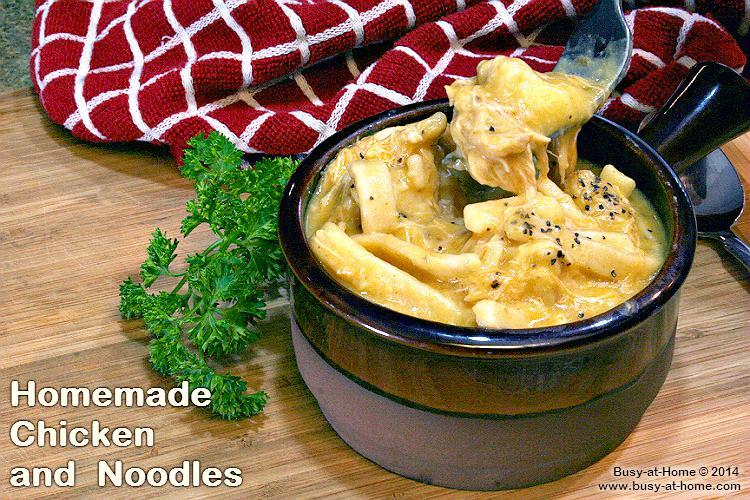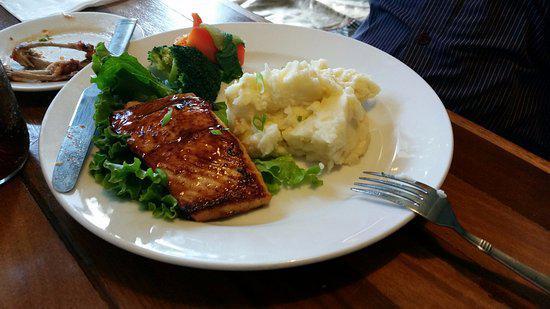The first image is the image on the left, the second image is the image on the right. Assess this claim about the two images: "A dish featuring mashed potatoes with gravy has a bright red rim.". Correct or not? Answer yes or no. No. The first image is the image on the left, the second image is the image on the right. Analyze the images presented: Is the assertion "In one image there is one or more utensils on the plate." valid? Answer yes or no. Yes. 